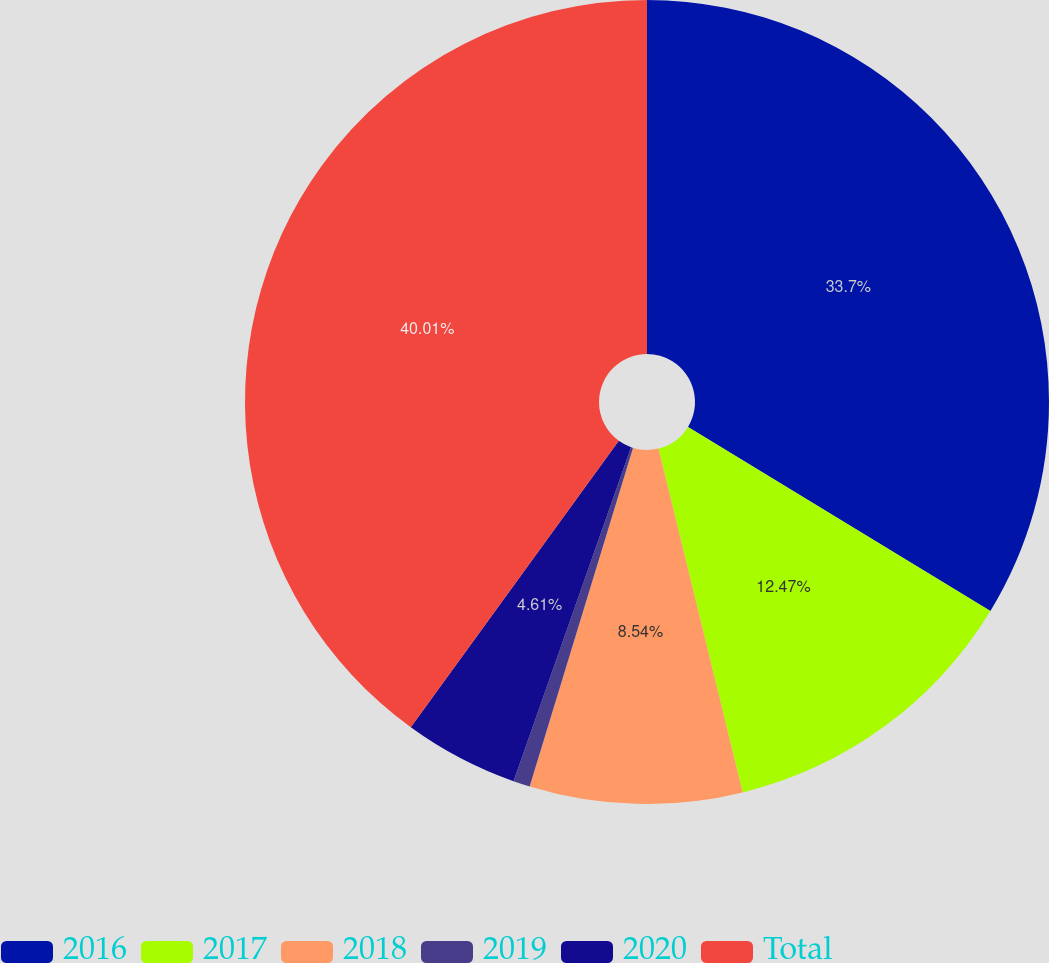Convert chart to OTSL. <chart><loc_0><loc_0><loc_500><loc_500><pie_chart><fcel>2016<fcel>2017<fcel>2018<fcel>2019<fcel>2020<fcel>Total<nl><fcel>33.7%<fcel>12.47%<fcel>8.54%<fcel>0.67%<fcel>4.61%<fcel>40.0%<nl></chart> 